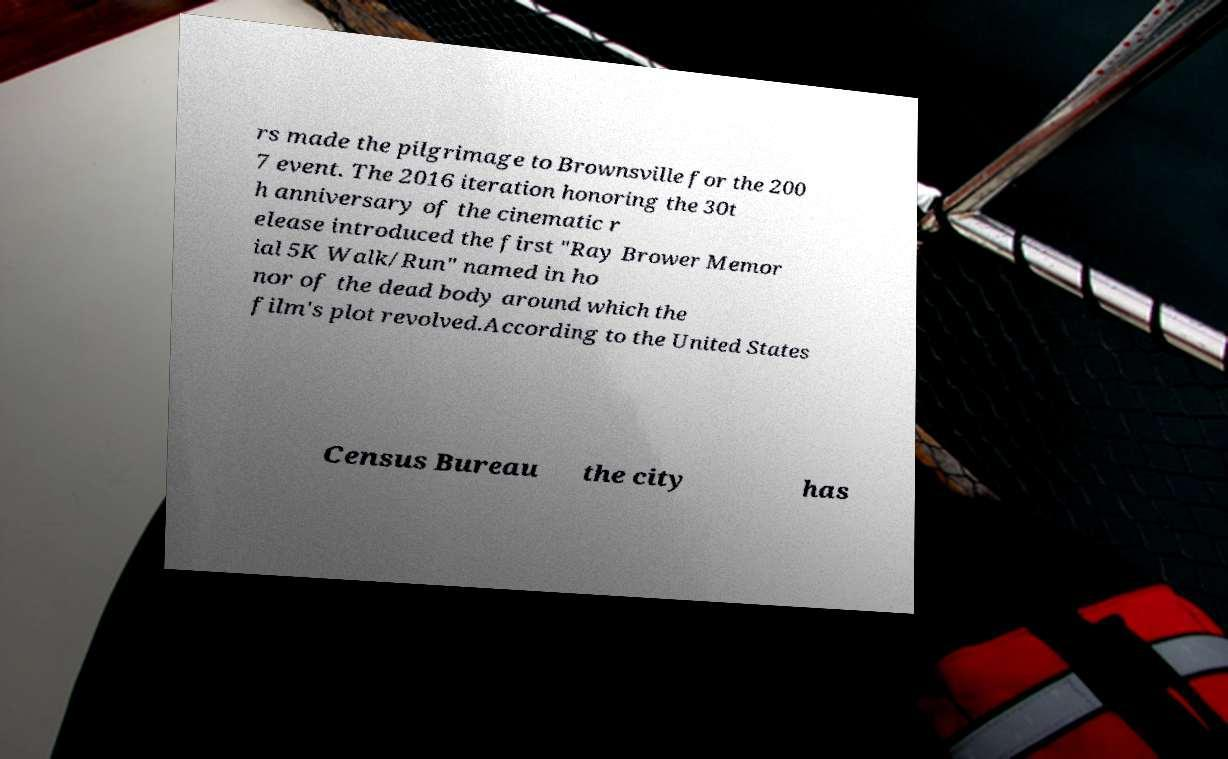For documentation purposes, I need the text within this image transcribed. Could you provide that? rs made the pilgrimage to Brownsville for the 200 7 event. The 2016 iteration honoring the 30t h anniversary of the cinematic r elease introduced the first "Ray Brower Memor ial 5K Walk/Run" named in ho nor of the dead body around which the film's plot revolved.According to the United States Census Bureau the city has 